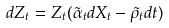Convert formula to latex. <formula><loc_0><loc_0><loc_500><loc_500>d Z _ { t } = Z _ { t } ( \tilde { \alpha } _ { t } d X _ { t } - \tilde { \rho } _ { t } d t )</formula> 